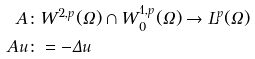Convert formula to latex. <formula><loc_0><loc_0><loc_500><loc_500>A & \colon W ^ { 2 , p } ( \Omega ) \cap W ^ { 1 , p } _ { 0 } ( \Omega ) \to L ^ { p } ( \Omega ) \\ A u & \colon = - \Delta u</formula> 